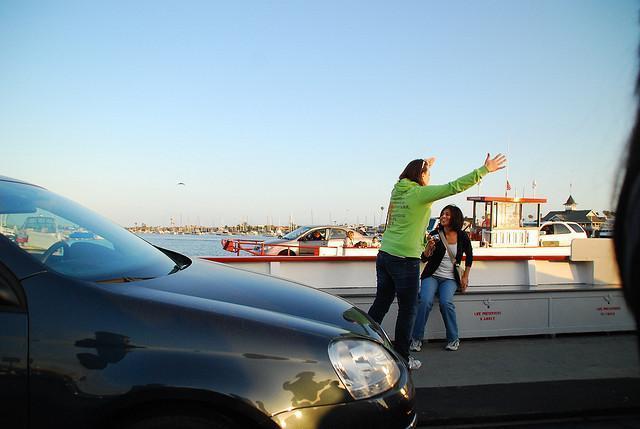How many people are visible?
Give a very brief answer. 3. How many cars are in the photo?
Give a very brief answer. 2. 